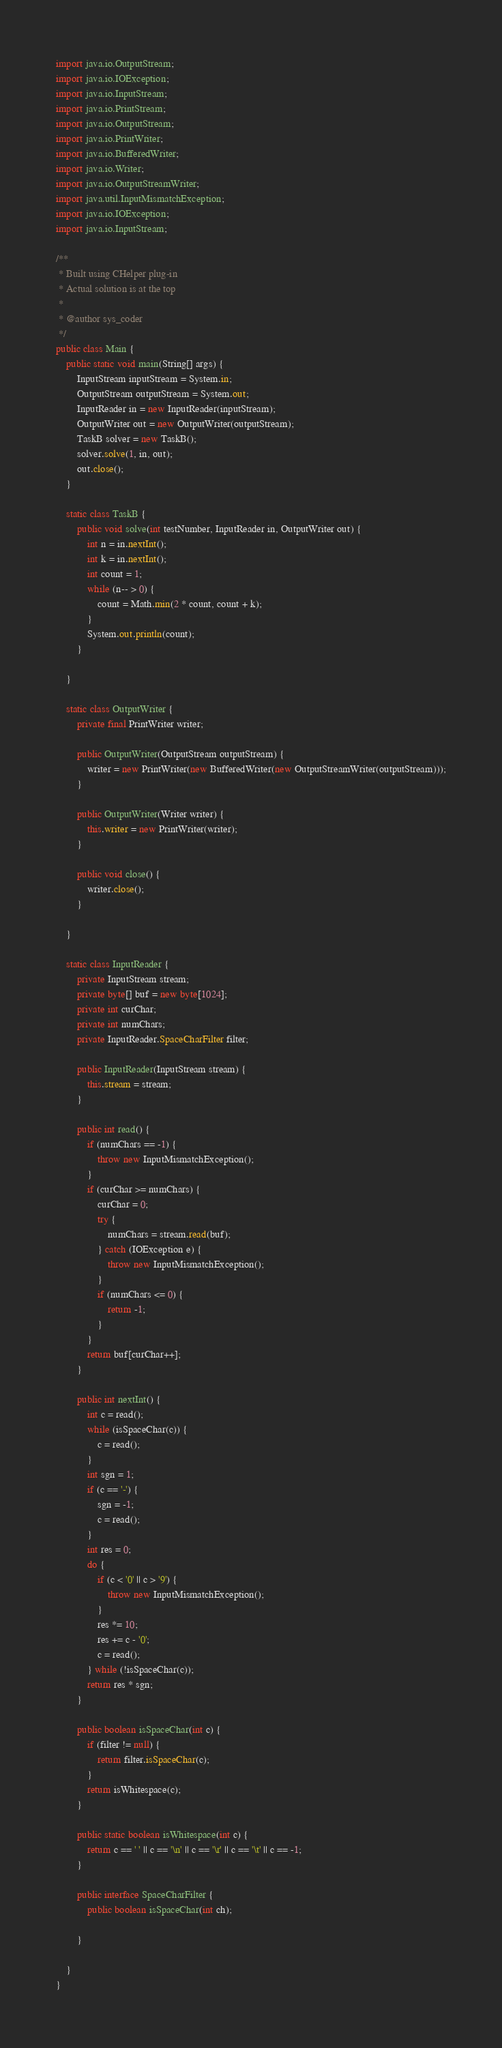<code> <loc_0><loc_0><loc_500><loc_500><_Java_>import java.io.OutputStream;
import java.io.IOException;
import java.io.InputStream;
import java.io.PrintStream;
import java.io.OutputStream;
import java.io.PrintWriter;
import java.io.BufferedWriter;
import java.io.Writer;
import java.io.OutputStreamWriter;
import java.util.InputMismatchException;
import java.io.IOException;
import java.io.InputStream;

/**
 * Built using CHelper plug-in
 * Actual solution is at the top
 *
 * @author sys_coder
 */
public class Main {
    public static void main(String[] args) {
        InputStream inputStream = System.in;
        OutputStream outputStream = System.out;
        InputReader in = new InputReader(inputStream);
        OutputWriter out = new OutputWriter(outputStream);
        TaskB solver = new TaskB();
        solver.solve(1, in, out);
        out.close();
    }

    static class TaskB {
        public void solve(int testNumber, InputReader in, OutputWriter out) {
            int n = in.nextInt();
            int k = in.nextInt();
            int count = 1;
            while (n-- > 0) {
                count = Math.min(2 * count, count + k);
            }
            System.out.println(count);
        }

    }

    static class OutputWriter {
        private final PrintWriter writer;

        public OutputWriter(OutputStream outputStream) {
            writer = new PrintWriter(new BufferedWriter(new OutputStreamWriter(outputStream)));
        }

        public OutputWriter(Writer writer) {
            this.writer = new PrintWriter(writer);
        }

        public void close() {
            writer.close();
        }

    }

    static class InputReader {
        private InputStream stream;
        private byte[] buf = new byte[1024];
        private int curChar;
        private int numChars;
        private InputReader.SpaceCharFilter filter;

        public InputReader(InputStream stream) {
            this.stream = stream;
        }

        public int read() {
            if (numChars == -1) {
                throw new InputMismatchException();
            }
            if (curChar >= numChars) {
                curChar = 0;
                try {
                    numChars = stream.read(buf);
                } catch (IOException e) {
                    throw new InputMismatchException();
                }
                if (numChars <= 0) {
                    return -1;
                }
            }
            return buf[curChar++];
        }

        public int nextInt() {
            int c = read();
            while (isSpaceChar(c)) {
                c = read();
            }
            int sgn = 1;
            if (c == '-') {
                sgn = -1;
                c = read();
            }
            int res = 0;
            do {
                if (c < '0' || c > '9') {
                    throw new InputMismatchException();
                }
                res *= 10;
                res += c - '0';
                c = read();
            } while (!isSpaceChar(c));
            return res * sgn;
        }

        public boolean isSpaceChar(int c) {
            if (filter != null) {
                return filter.isSpaceChar(c);
            }
            return isWhitespace(c);
        }

        public static boolean isWhitespace(int c) {
            return c == ' ' || c == '\n' || c == '\r' || c == '\t' || c == -1;
        }

        public interface SpaceCharFilter {
            public boolean isSpaceChar(int ch);

        }

    }
}

</code> 